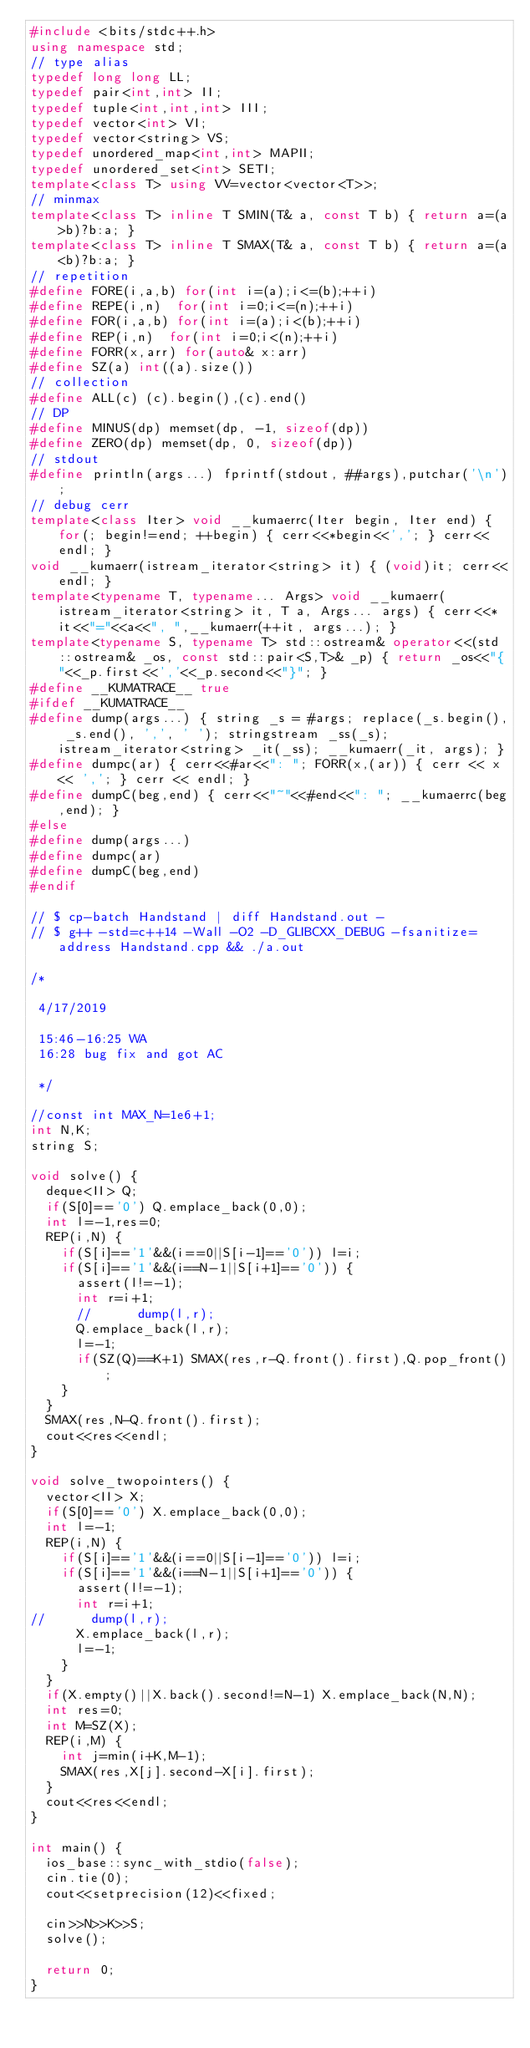Convert code to text. <code><loc_0><loc_0><loc_500><loc_500><_C++_>#include <bits/stdc++.h>
using namespace std;
// type alias
typedef long long LL;
typedef pair<int,int> II;
typedef tuple<int,int,int> III;
typedef vector<int> VI;
typedef vector<string> VS;
typedef unordered_map<int,int> MAPII;
typedef unordered_set<int> SETI;
template<class T> using VV=vector<vector<T>>;
// minmax
template<class T> inline T SMIN(T& a, const T b) { return a=(a>b)?b:a; }
template<class T> inline T SMAX(T& a, const T b) { return a=(a<b)?b:a; }
// repetition
#define FORE(i,a,b) for(int i=(a);i<=(b);++i)
#define REPE(i,n)  for(int i=0;i<=(n);++i)
#define FOR(i,a,b) for(int i=(a);i<(b);++i)
#define REP(i,n)  for(int i=0;i<(n);++i)
#define FORR(x,arr) for(auto& x:arr)
#define SZ(a) int((a).size())
// collection
#define ALL(c) (c).begin(),(c).end()
// DP
#define MINUS(dp) memset(dp, -1, sizeof(dp))
#define ZERO(dp) memset(dp, 0, sizeof(dp))
// stdout
#define println(args...) fprintf(stdout, ##args),putchar('\n');
// debug cerr
template<class Iter> void __kumaerrc(Iter begin, Iter end) { for(; begin!=end; ++begin) { cerr<<*begin<<','; } cerr<<endl; }
void __kumaerr(istream_iterator<string> it) { (void)it; cerr<<endl; }
template<typename T, typename... Args> void __kumaerr(istream_iterator<string> it, T a, Args... args) { cerr<<*it<<"="<<a<<", ",__kumaerr(++it, args...); }
template<typename S, typename T> std::ostream& operator<<(std::ostream& _os, const std::pair<S,T>& _p) { return _os<<"{"<<_p.first<<','<<_p.second<<"}"; }
#define __KUMATRACE__ true
#ifdef __KUMATRACE__
#define dump(args...) { string _s = #args; replace(_s.begin(), _s.end(), ',', ' '); stringstream _ss(_s); istream_iterator<string> _it(_ss); __kumaerr(_it, args); }
#define dumpc(ar) { cerr<<#ar<<": "; FORR(x,(ar)) { cerr << x << ','; } cerr << endl; }
#define dumpC(beg,end) { cerr<<"~"<<#end<<": "; __kumaerrc(beg,end); }
#else
#define dump(args...)
#define dumpc(ar)
#define dumpC(beg,end)
#endif

// $ cp-batch Handstand | diff Handstand.out -
// $ g++ -std=c++14 -Wall -O2 -D_GLIBCXX_DEBUG -fsanitize=address Handstand.cpp && ./a.out

/*
 
 4/17/2019
 
 15:46-16:25 WA
 16:28 bug fix and got AC
 
 */

//const int MAX_N=1e6+1;
int N,K;
string S;

void solve() {
  deque<II> Q;
  if(S[0]=='0') Q.emplace_back(0,0);
  int l=-1,res=0;
  REP(i,N) {
    if(S[i]=='1'&&(i==0||S[i-1]=='0')) l=i;
    if(S[i]=='1'&&(i==N-1||S[i+1]=='0')) {
      assert(l!=-1);
      int r=i+1;
      //      dump(l,r);
      Q.emplace_back(l,r);
      l=-1;
      if(SZ(Q)==K+1) SMAX(res,r-Q.front().first),Q.pop_front();
    }
  }
  SMAX(res,N-Q.front().first);
  cout<<res<<endl;
}

void solve_twopointers() {
  vector<II> X;
  if(S[0]=='0') X.emplace_back(0,0);
  int l=-1;
  REP(i,N) {
    if(S[i]=='1'&&(i==0||S[i-1]=='0')) l=i;
    if(S[i]=='1'&&(i==N-1||S[i+1]=='0')) {
      assert(l!=-1);
      int r=i+1;
//      dump(l,r);
      X.emplace_back(l,r);
      l=-1;
    }
  }
  if(X.empty()||X.back().second!=N-1) X.emplace_back(N,N);
  int res=0;
  int M=SZ(X);
  REP(i,M) {
    int j=min(i+K,M-1);
    SMAX(res,X[j].second-X[i].first);
  }
  cout<<res<<endl;
}

int main() {
  ios_base::sync_with_stdio(false);
  cin.tie(0);
  cout<<setprecision(12)<<fixed;
  
  cin>>N>>K>>S;
  solve();
  
  return 0;
}
</code> 